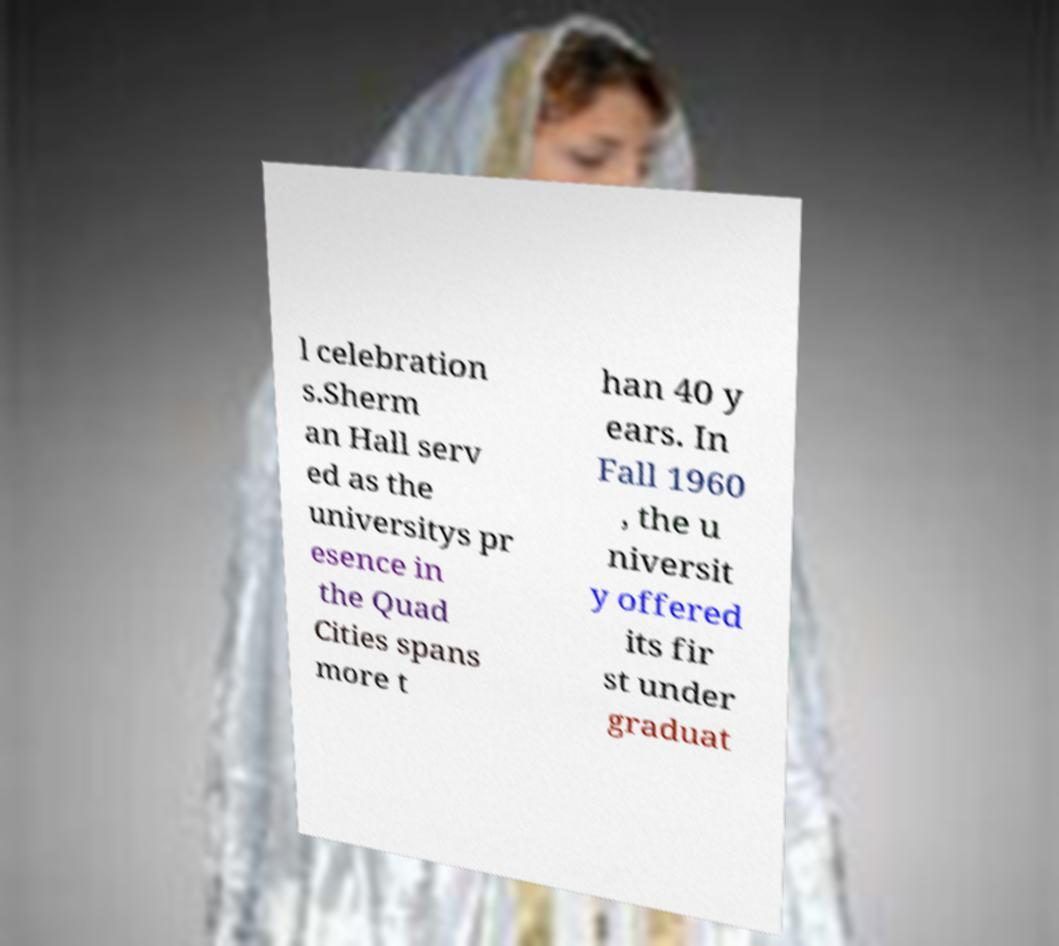Can you accurately transcribe the text from the provided image for me? l celebration s.Sherm an Hall serv ed as the universitys pr esence in the Quad Cities spans more t han 40 y ears. In Fall 1960 , the u niversit y offered its fir st under graduat 